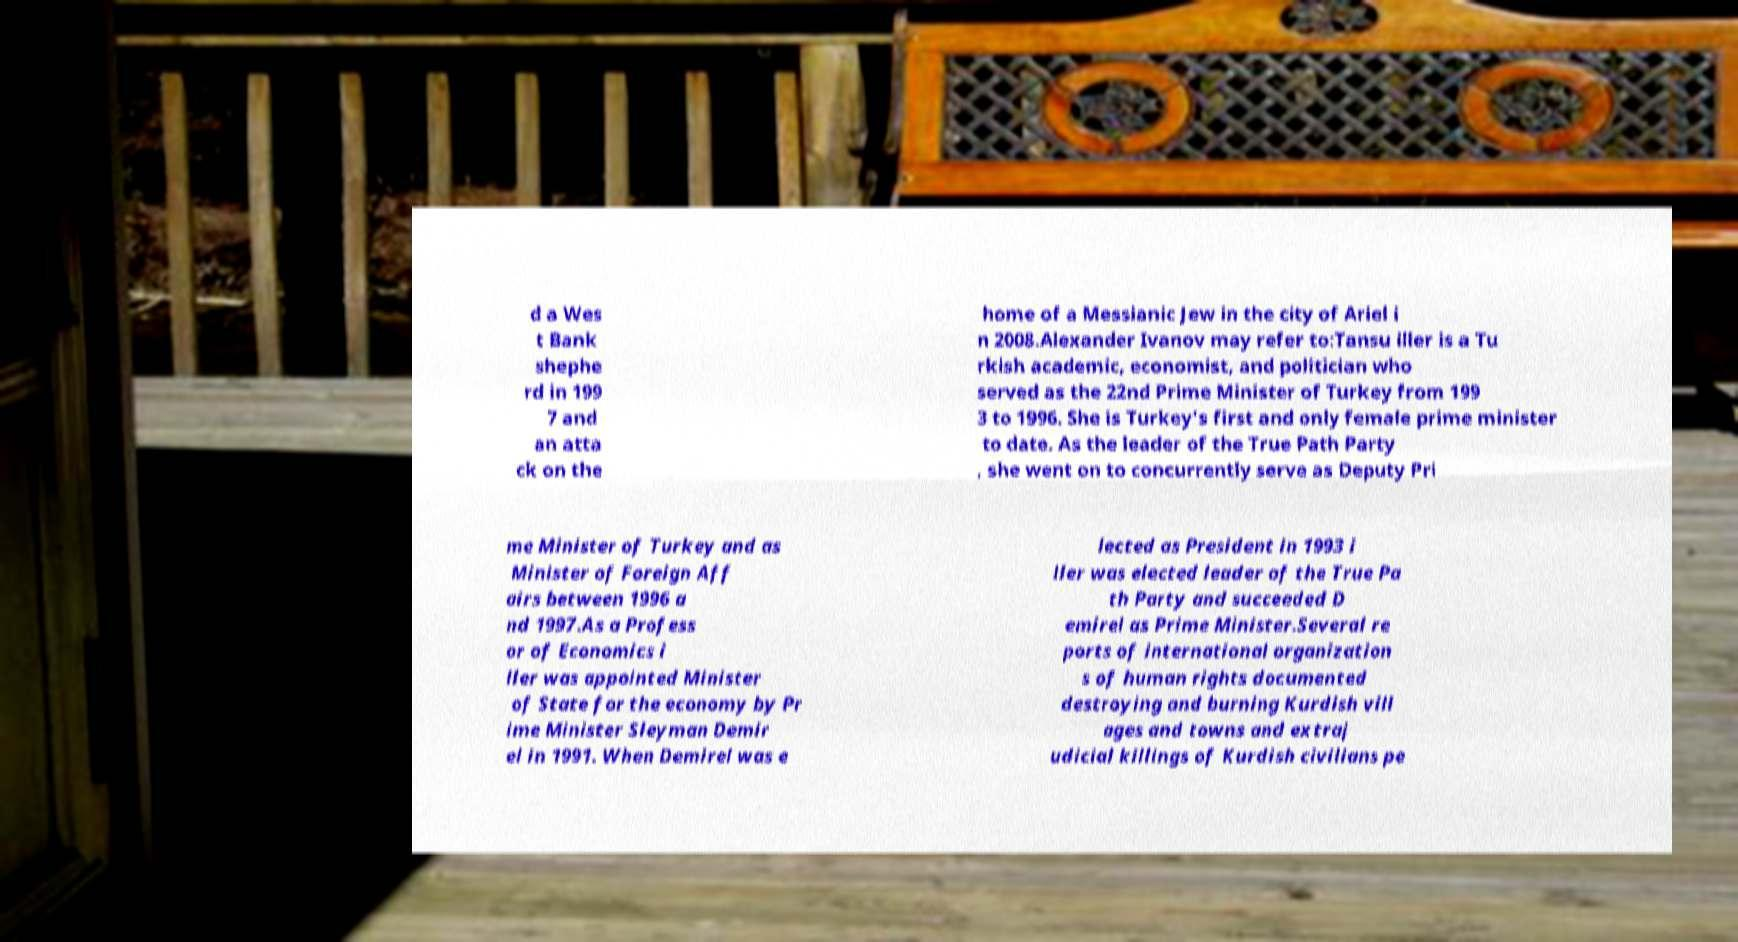For documentation purposes, I need the text within this image transcribed. Could you provide that? d a Wes t Bank shephe rd in 199 7 and an atta ck on the home of a Messianic Jew in the city of Ariel i n 2008.Alexander Ivanov may refer to:Tansu iller is a Tu rkish academic, economist, and politician who served as the 22nd Prime Minister of Turkey from 199 3 to 1996. She is Turkey's first and only female prime minister to date. As the leader of the True Path Party , she went on to concurrently serve as Deputy Pri me Minister of Turkey and as Minister of Foreign Aff airs between 1996 a nd 1997.As a Profess or of Economics i ller was appointed Minister of State for the economy by Pr ime Minister Sleyman Demir el in 1991. When Demirel was e lected as President in 1993 i ller was elected leader of the True Pa th Party and succeeded D emirel as Prime Minister.Several re ports of international organization s of human rights documented destroying and burning Kurdish vill ages and towns and extraj udicial killings of Kurdish civilians pe 